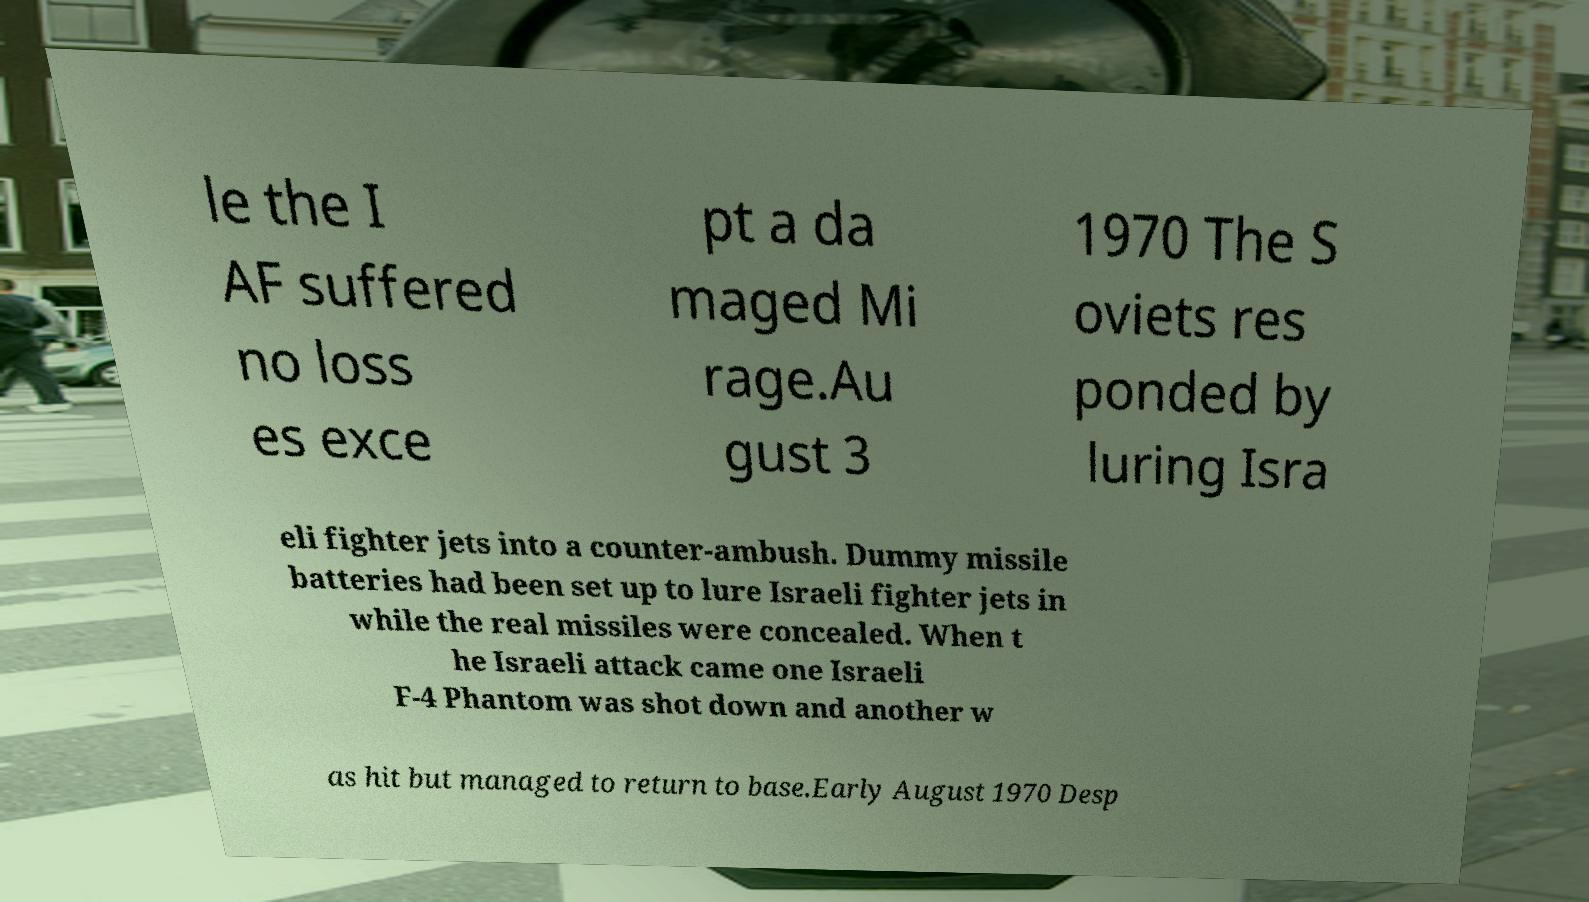For documentation purposes, I need the text within this image transcribed. Could you provide that? le the I AF suffered no loss es exce pt a da maged Mi rage.Au gust 3 1970 The S oviets res ponded by luring Isra eli fighter jets into a counter-ambush. Dummy missile batteries had been set up to lure Israeli fighter jets in while the real missiles were concealed. When t he Israeli attack came one Israeli F-4 Phantom was shot down and another w as hit but managed to return to base.Early August 1970 Desp 